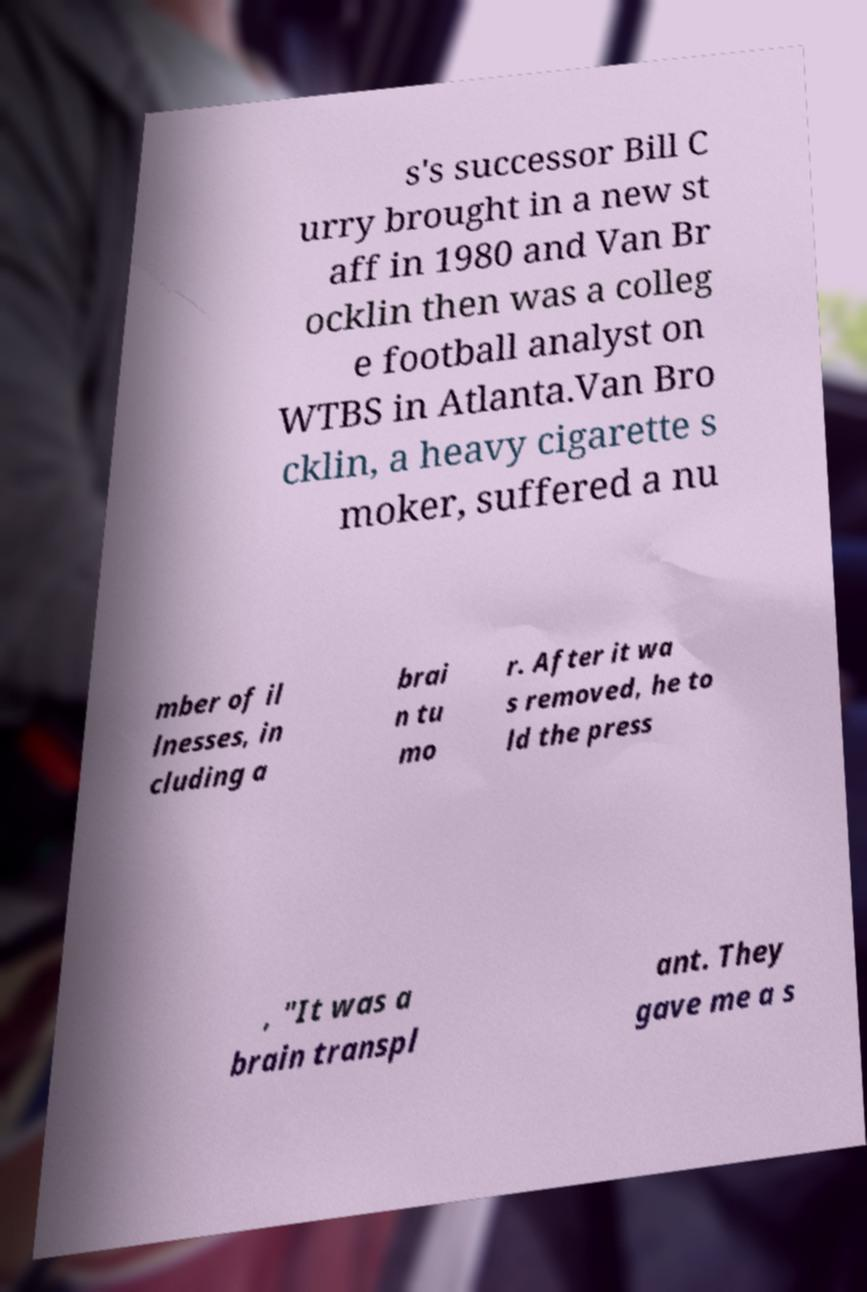For documentation purposes, I need the text within this image transcribed. Could you provide that? s's successor Bill C urry brought in a new st aff in 1980 and Van Br ocklin then was a colleg e football analyst on WTBS in Atlanta.Van Bro cklin, a heavy cigarette s moker, suffered a nu mber of il lnesses, in cluding a brai n tu mo r. After it wa s removed, he to ld the press , "It was a brain transpl ant. They gave me a s 